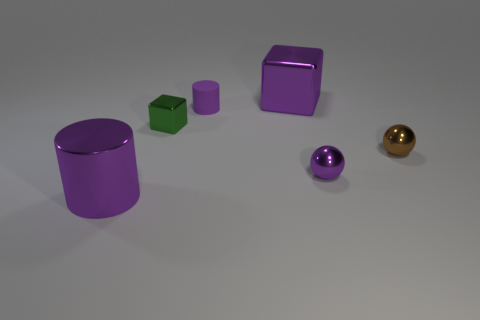Are there more round objects or square objects in this image? In the image, there are two round objects and two objects with square or rectangular faces, so the numbers are equal. 